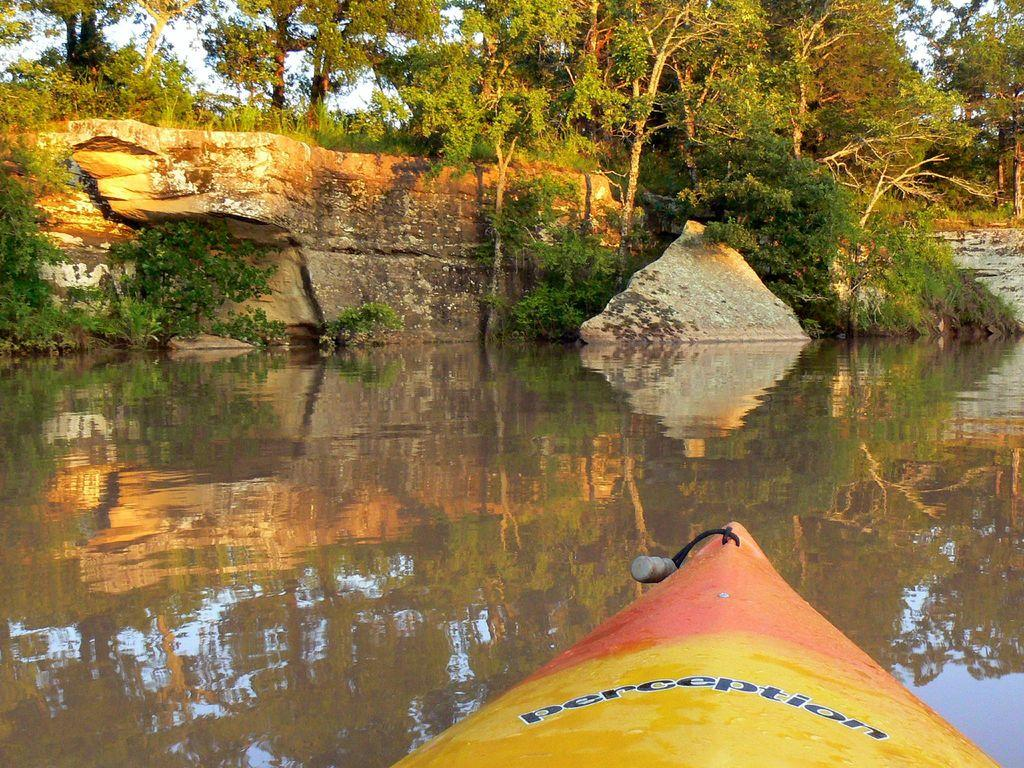What is the main subject of the image? The main subject of the image is a boat. Where is the boat located? The boat is on the water. What can be seen in the background of the image? There are rocks and trees in the background of the image. What shape is the wall in the middle of the image? There is no wall present in the image; it features a boat on the water with rocks and trees in the background. 